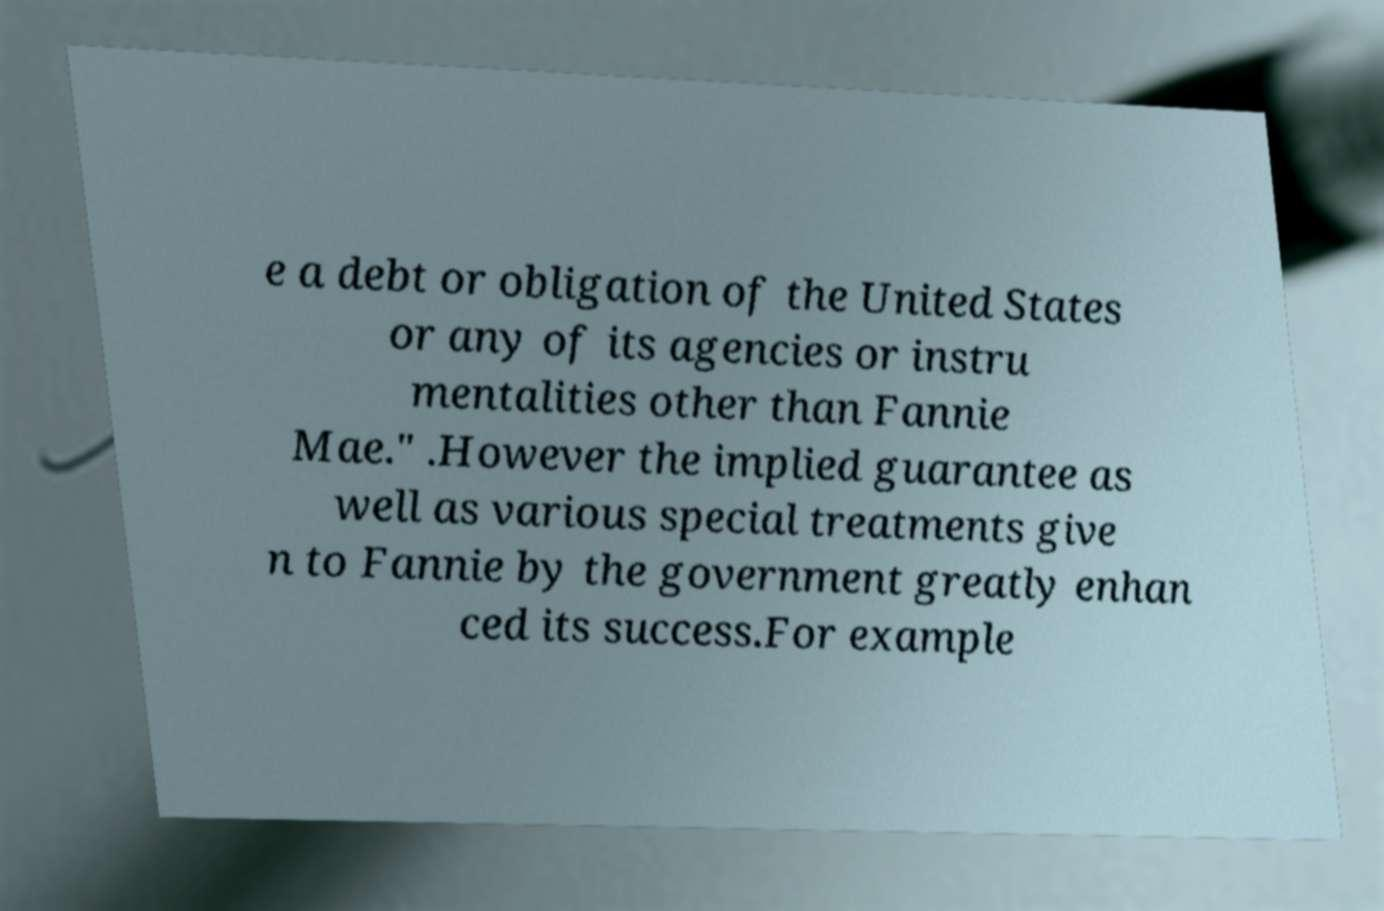Could you assist in decoding the text presented in this image and type it out clearly? e a debt or obligation of the United States or any of its agencies or instru mentalities other than Fannie Mae." .However the implied guarantee as well as various special treatments give n to Fannie by the government greatly enhan ced its success.For example 